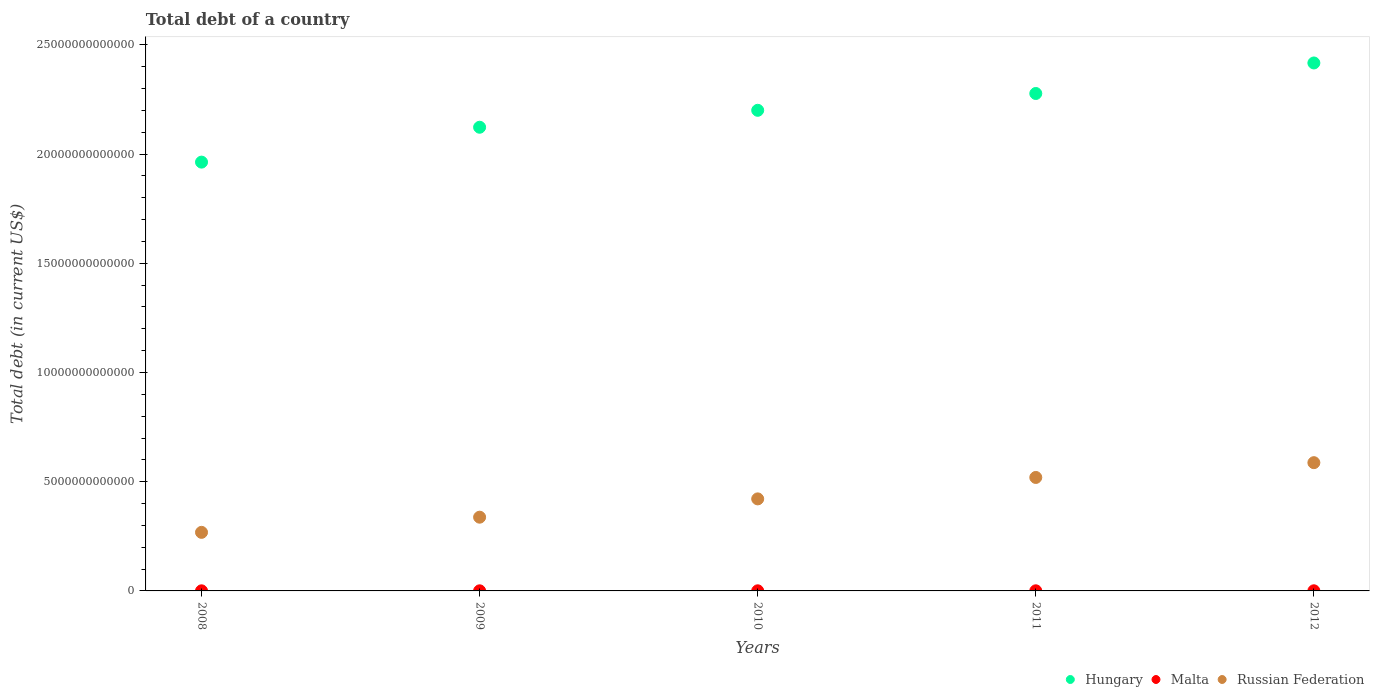Is the number of dotlines equal to the number of legend labels?
Give a very brief answer. Yes. What is the debt in Russian Federation in 2012?
Your answer should be compact. 5.87e+12. Across all years, what is the maximum debt in Hungary?
Keep it short and to the point. 2.42e+13. Across all years, what is the minimum debt in Malta?
Your response must be concise. 4.43e+09. In which year was the debt in Russian Federation minimum?
Your response must be concise. 2008. What is the total debt in Russian Federation in the graph?
Your answer should be compact. 2.13e+13. What is the difference between the debt in Malta in 2008 and that in 2010?
Make the answer very short. -6.83e+08. What is the difference between the debt in Malta in 2008 and the debt in Russian Federation in 2012?
Offer a very short reply. -5.87e+12. What is the average debt in Malta per year?
Your answer should be very brief. 5.16e+09. In the year 2012, what is the difference between the debt in Malta and debt in Hungary?
Ensure brevity in your answer.  -2.42e+13. In how many years, is the debt in Hungary greater than 18000000000000 US$?
Offer a terse response. 5. What is the ratio of the debt in Malta in 2008 to that in 2011?
Your response must be concise. 0.8. Is the debt in Malta in 2008 less than that in 2012?
Make the answer very short. Yes. Is the difference between the debt in Malta in 2010 and 2011 greater than the difference between the debt in Hungary in 2010 and 2011?
Give a very brief answer. Yes. What is the difference between the highest and the second highest debt in Russian Federation?
Give a very brief answer. 6.77e+11. What is the difference between the highest and the lowest debt in Russian Federation?
Ensure brevity in your answer.  3.19e+12. In how many years, is the debt in Hungary greater than the average debt in Hungary taken over all years?
Your answer should be compact. 3. Is the debt in Hungary strictly less than the debt in Russian Federation over the years?
Your answer should be very brief. No. How many years are there in the graph?
Your response must be concise. 5. What is the difference between two consecutive major ticks on the Y-axis?
Keep it short and to the point. 5.00e+12. Does the graph contain any zero values?
Offer a very short reply. No. Does the graph contain grids?
Ensure brevity in your answer.  No. How many legend labels are there?
Your answer should be very brief. 3. What is the title of the graph?
Offer a very short reply. Total debt of a country. What is the label or title of the Y-axis?
Make the answer very short. Total debt (in current US$). What is the Total debt (in current US$) of Hungary in 2008?
Offer a very short reply. 1.96e+13. What is the Total debt (in current US$) in Malta in 2008?
Make the answer very short. 4.43e+09. What is the Total debt (in current US$) of Russian Federation in 2008?
Ensure brevity in your answer.  2.68e+12. What is the Total debt (in current US$) of Hungary in 2009?
Give a very brief answer. 2.12e+13. What is the Total debt (in current US$) in Malta in 2009?
Keep it short and to the point. 4.78e+09. What is the Total debt (in current US$) in Russian Federation in 2009?
Your answer should be very brief. 3.38e+12. What is the Total debt (in current US$) in Hungary in 2010?
Offer a very short reply. 2.20e+13. What is the Total debt (in current US$) in Malta in 2010?
Offer a very short reply. 5.11e+09. What is the Total debt (in current US$) in Russian Federation in 2010?
Offer a very short reply. 4.21e+12. What is the Total debt (in current US$) of Hungary in 2011?
Ensure brevity in your answer.  2.28e+13. What is the Total debt (in current US$) of Malta in 2011?
Offer a very short reply. 5.54e+09. What is the Total debt (in current US$) of Russian Federation in 2011?
Provide a short and direct response. 5.19e+12. What is the Total debt (in current US$) in Hungary in 2012?
Your answer should be very brief. 2.42e+13. What is the Total debt (in current US$) in Malta in 2012?
Give a very brief answer. 5.94e+09. What is the Total debt (in current US$) of Russian Federation in 2012?
Give a very brief answer. 5.87e+12. Across all years, what is the maximum Total debt (in current US$) in Hungary?
Offer a terse response. 2.42e+13. Across all years, what is the maximum Total debt (in current US$) in Malta?
Provide a succinct answer. 5.94e+09. Across all years, what is the maximum Total debt (in current US$) in Russian Federation?
Offer a terse response. 5.87e+12. Across all years, what is the minimum Total debt (in current US$) in Hungary?
Your response must be concise. 1.96e+13. Across all years, what is the minimum Total debt (in current US$) of Malta?
Offer a terse response. 4.43e+09. Across all years, what is the minimum Total debt (in current US$) in Russian Federation?
Your response must be concise. 2.68e+12. What is the total Total debt (in current US$) in Hungary in the graph?
Ensure brevity in your answer.  1.10e+14. What is the total Total debt (in current US$) of Malta in the graph?
Provide a short and direct response. 2.58e+1. What is the total Total debt (in current US$) in Russian Federation in the graph?
Keep it short and to the point. 2.13e+13. What is the difference between the Total debt (in current US$) of Hungary in 2008 and that in 2009?
Keep it short and to the point. -1.60e+12. What is the difference between the Total debt (in current US$) in Malta in 2008 and that in 2009?
Your response must be concise. -3.48e+08. What is the difference between the Total debt (in current US$) of Russian Federation in 2008 and that in 2009?
Your answer should be compact. -6.94e+11. What is the difference between the Total debt (in current US$) in Hungary in 2008 and that in 2010?
Your answer should be very brief. -2.37e+12. What is the difference between the Total debt (in current US$) in Malta in 2008 and that in 2010?
Keep it short and to the point. -6.83e+08. What is the difference between the Total debt (in current US$) in Russian Federation in 2008 and that in 2010?
Your answer should be compact. -1.53e+12. What is the difference between the Total debt (in current US$) in Hungary in 2008 and that in 2011?
Provide a succinct answer. -3.14e+12. What is the difference between the Total debt (in current US$) of Malta in 2008 and that in 2011?
Provide a short and direct response. -1.11e+09. What is the difference between the Total debt (in current US$) in Russian Federation in 2008 and that in 2011?
Ensure brevity in your answer.  -2.51e+12. What is the difference between the Total debt (in current US$) of Hungary in 2008 and that in 2012?
Your answer should be very brief. -4.54e+12. What is the difference between the Total debt (in current US$) in Malta in 2008 and that in 2012?
Offer a very short reply. -1.51e+09. What is the difference between the Total debt (in current US$) of Russian Federation in 2008 and that in 2012?
Offer a very short reply. -3.19e+12. What is the difference between the Total debt (in current US$) of Hungary in 2009 and that in 2010?
Keep it short and to the point. -7.75e+11. What is the difference between the Total debt (in current US$) in Malta in 2009 and that in 2010?
Your answer should be compact. -3.35e+08. What is the difference between the Total debt (in current US$) in Russian Federation in 2009 and that in 2010?
Ensure brevity in your answer.  -8.38e+11. What is the difference between the Total debt (in current US$) in Hungary in 2009 and that in 2011?
Your answer should be compact. -1.54e+12. What is the difference between the Total debt (in current US$) in Malta in 2009 and that in 2011?
Ensure brevity in your answer.  -7.62e+08. What is the difference between the Total debt (in current US$) in Russian Federation in 2009 and that in 2011?
Provide a succinct answer. -1.82e+12. What is the difference between the Total debt (in current US$) of Hungary in 2009 and that in 2012?
Provide a short and direct response. -2.94e+12. What is the difference between the Total debt (in current US$) of Malta in 2009 and that in 2012?
Offer a very short reply. -1.16e+09. What is the difference between the Total debt (in current US$) of Russian Federation in 2009 and that in 2012?
Your answer should be compact. -2.50e+12. What is the difference between the Total debt (in current US$) in Hungary in 2010 and that in 2011?
Offer a very short reply. -7.70e+11. What is the difference between the Total debt (in current US$) in Malta in 2010 and that in 2011?
Provide a short and direct response. -4.27e+08. What is the difference between the Total debt (in current US$) in Russian Federation in 2010 and that in 2011?
Give a very brief answer. -9.81e+11. What is the difference between the Total debt (in current US$) in Hungary in 2010 and that in 2012?
Offer a very short reply. -2.17e+12. What is the difference between the Total debt (in current US$) of Malta in 2010 and that in 2012?
Your answer should be very brief. -8.29e+08. What is the difference between the Total debt (in current US$) of Russian Federation in 2010 and that in 2012?
Your answer should be very brief. -1.66e+12. What is the difference between the Total debt (in current US$) in Hungary in 2011 and that in 2012?
Keep it short and to the point. -1.40e+12. What is the difference between the Total debt (in current US$) of Malta in 2011 and that in 2012?
Your answer should be very brief. -4.02e+08. What is the difference between the Total debt (in current US$) of Russian Federation in 2011 and that in 2012?
Offer a terse response. -6.77e+11. What is the difference between the Total debt (in current US$) in Hungary in 2008 and the Total debt (in current US$) in Malta in 2009?
Offer a terse response. 1.96e+13. What is the difference between the Total debt (in current US$) of Hungary in 2008 and the Total debt (in current US$) of Russian Federation in 2009?
Provide a succinct answer. 1.63e+13. What is the difference between the Total debt (in current US$) in Malta in 2008 and the Total debt (in current US$) in Russian Federation in 2009?
Give a very brief answer. -3.37e+12. What is the difference between the Total debt (in current US$) of Hungary in 2008 and the Total debt (in current US$) of Malta in 2010?
Your response must be concise. 1.96e+13. What is the difference between the Total debt (in current US$) in Hungary in 2008 and the Total debt (in current US$) in Russian Federation in 2010?
Your answer should be very brief. 1.54e+13. What is the difference between the Total debt (in current US$) in Malta in 2008 and the Total debt (in current US$) in Russian Federation in 2010?
Make the answer very short. -4.21e+12. What is the difference between the Total debt (in current US$) of Hungary in 2008 and the Total debt (in current US$) of Malta in 2011?
Offer a very short reply. 1.96e+13. What is the difference between the Total debt (in current US$) in Hungary in 2008 and the Total debt (in current US$) in Russian Federation in 2011?
Your response must be concise. 1.44e+13. What is the difference between the Total debt (in current US$) of Malta in 2008 and the Total debt (in current US$) of Russian Federation in 2011?
Your answer should be compact. -5.19e+12. What is the difference between the Total debt (in current US$) in Hungary in 2008 and the Total debt (in current US$) in Malta in 2012?
Make the answer very short. 1.96e+13. What is the difference between the Total debt (in current US$) of Hungary in 2008 and the Total debt (in current US$) of Russian Federation in 2012?
Offer a terse response. 1.38e+13. What is the difference between the Total debt (in current US$) in Malta in 2008 and the Total debt (in current US$) in Russian Federation in 2012?
Ensure brevity in your answer.  -5.87e+12. What is the difference between the Total debt (in current US$) of Hungary in 2009 and the Total debt (in current US$) of Malta in 2010?
Offer a terse response. 2.12e+13. What is the difference between the Total debt (in current US$) in Hungary in 2009 and the Total debt (in current US$) in Russian Federation in 2010?
Your answer should be compact. 1.70e+13. What is the difference between the Total debt (in current US$) in Malta in 2009 and the Total debt (in current US$) in Russian Federation in 2010?
Make the answer very short. -4.21e+12. What is the difference between the Total debt (in current US$) of Hungary in 2009 and the Total debt (in current US$) of Malta in 2011?
Offer a terse response. 2.12e+13. What is the difference between the Total debt (in current US$) of Hungary in 2009 and the Total debt (in current US$) of Russian Federation in 2011?
Your answer should be compact. 1.60e+13. What is the difference between the Total debt (in current US$) of Malta in 2009 and the Total debt (in current US$) of Russian Federation in 2011?
Ensure brevity in your answer.  -5.19e+12. What is the difference between the Total debt (in current US$) in Hungary in 2009 and the Total debt (in current US$) in Malta in 2012?
Ensure brevity in your answer.  2.12e+13. What is the difference between the Total debt (in current US$) in Hungary in 2009 and the Total debt (in current US$) in Russian Federation in 2012?
Your answer should be compact. 1.54e+13. What is the difference between the Total debt (in current US$) of Malta in 2009 and the Total debt (in current US$) of Russian Federation in 2012?
Your response must be concise. -5.87e+12. What is the difference between the Total debt (in current US$) in Hungary in 2010 and the Total debt (in current US$) in Malta in 2011?
Your answer should be compact. 2.20e+13. What is the difference between the Total debt (in current US$) of Hungary in 2010 and the Total debt (in current US$) of Russian Federation in 2011?
Make the answer very short. 1.68e+13. What is the difference between the Total debt (in current US$) of Malta in 2010 and the Total debt (in current US$) of Russian Federation in 2011?
Make the answer very short. -5.19e+12. What is the difference between the Total debt (in current US$) in Hungary in 2010 and the Total debt (in current US$) in Malta in 2012?
Your response must be concise. 2.20e+13. What is the difference between the Total debt (in current US$) of Hungary in 2010 and the Total debt (in current US$) of Russian Federation in 2012?
Provide a succinct answer. 1.61e+13. What is the difference between the Total debt (in current US$) in Malta in 2010 and the Total debt (in current US$) in Russian Federation in 2012?
Your answer should be compact. -5.87e+12. What is the difference between the Total debt (in current US$) in Hungary in 2011 and the Total debt (in current US$) in Malta in 2012?
Give a very brief answer. 2.28e+13. What is the difference between the Total debt (in current US$) of Hungary in 2011 and the Total debt (in current US$) of Russian Federation in 2012?
Give a very brief answer. 1.69e+13. What is the difference between the Total debt (in current US$) in Malta in 2011 and the Total debt (in current US$) in Russian Federation in 2012?
Give a very brief answer. -5.87e+12. What is the average Total debt (in current US$) of Hungary per year?
Keep it short and to the point. 2.20e+13. What is the average Total debt (in current US$) in Malta per year?
Your answer should be compact. 5.16e+09. What is the average Total debt (in current US$) in Russian Federation per year?
Offer a terse response. 4.27e+12. In the year 2008, what is the difference between the Total debt (in current US$) in Hungary and Total debt (in current US$) in Malta?
Keep it short and to the point. 1.96e+13. In the year 2008, what is the difference between the Total debt (in current US$) of Hungary and Total debt (in current US$) of Russian Federation?
Your response must be concise. 1.69e+13. In the year 2008, what is the difference between the Total debt (in current US$) in Malta and Total debt (in current US$) in Russian Federation?
Offer a very short reply. -2.68e+12. In the year 2009, what is the difference between the Total debt (in current US$) of Hungary and Total debt (in current US$) of Malta?
Provide a short and direct response. 2.12e+13. In the year 2009, what is the difference between the Total debt (in current US$) in Hungary and Total debt (in current US$) in Russian Federation?
Ensure brevity in your answer.  1.79e+13. In the year 2009, what is the difference between the Total debt (in current US$) in Malta and Total debt (in current US$) in Russian Federation?
Keep it short and to the point. -3.37e+12. In the year 2010, what is the difference between the Total debt (in current US$) of Hungary and Total debt (in current US$) of Malta?
Your answer should be compact. 2.20e+13. In the year 2010, what is the difference between the Total debt (in current US$) in Hungary and Total debt (in current US$) in Russian Federation?
Your response must be concise. 1.78e+13. In the year 2010, what is the difference between the Total debt (in current US$) of Malta and Total debt (in current US$) of Russian Federation?
Offer a very short reply. -4.21e+12. In the year 2011, what is the difference between the Total debt (in current US$) in Hungary and Total debt (in current US$) in Malta?
Provide a short and direct response. 2.28e+13. In the year 2011, what is the difference between the Total debt (in current US$) of Hungary and Total debt (in current US$) of Russian Federation?
Your response must be concise. 1.76e+13. In the year 2011, what is the difference between the Total debt (in current US$) in Malta and Total debt (in current US$) in Russian Federation?
Offer a terse response. -5.19e+12. In the year 2012, what is the difference between the Total debt (in current US$) of Hungary and Total debt (in current US$) of Malta?
Give a very brief answer. 2.42e+13. In the year 2012, what is the difference between the Total debt (in current US$) of Hungary and Total debt (in current US$) of Russian Federation?
Your answer should be very brief. 1.83e+13. In the year 2012, what is the difference between the Total debt (in current US$) in Malta and Total debt (in current US$) in Russian Federation?
Ensure brevity in your answer.  -5.87e+12. What is the ratio of the Total debt (in current US$) of Hungary in 2008 to that in 2009?
Your answer should be very brief. 0.92. What is the ratio of the Total debt (in current US$) in Malta in 2008 to that in 2009?
Provide a succinct answer. 0.93. What is the ratio of the Total debt (in current US$) of Russian Federation in 2008 to that in 2009?
Your response must be concise. 0.79. What is the ratio of the Total debt (in current US$) of Hungary in 2008 to that in 2010?
Ensure brevity in your answer.  0.89. What is the ratio of the Total debt (in current US$) in Malta in 2008 to that in 2010?
Your answer should be compact. 0.87. What is the ratio of the Total debt (in current US$) of Russian Federation in 2008 to that in 2010?
Give a very brief answer. 0.64. What is the ratio of the Total debt (in current US$) of Hungary in 2008 to that in 2011?
Keep it short and to the point. 0.86. What is the ratio of the Total debt (in current US$) of Malta in 2008 to that in 2011?
Your answer should be very brief. 0.8. What is the ratio of the Total debt (in current US$) of Russian Federation in 2008 to that in 2011?
Your response must be concise. 0.52. What is the ratio of the Total debt (in current US$) of Hungary in 2008 to that in 2012?
Provide a short and direct response. 0.81. What is the ratio of the Total debt (in current US$) in Malta in 2008 to that in 2012?
Offer a terse response. 0.75. What is the ratio of the Total debt (in current US$) in Russian Federation in 2008 to that in 2012?
Give a very brief answer. 0.46. What is the ratio of the Total debt (in current US$) of Hungary in 2009 to that in 2010?
Offer a very short reply. 0.96. What is the ratio of the Total debt (in current US$) of Malta in 2009 to that in 2010?
Make the answer very short. 0.93. What is the ratio of the Total debt (in current US$) in Russian Federation in 2009 to that in 2010?
Your answer should be very brief. 0.8. What is the ratio of the Total debt (in current US$) in Hungary in 2009 to that in 2011?
Provide a succinct answer. 0.93. What is the ratio of the Total debt (in current US$) in Malta in 2009 to that in 2011?
Your answer should be compact. 0.86. What is the ratio of the Total debt (in current US$) in Russian Federation in 2009 to that in 2011?
Your answer should be compact. 0.65. What is the ratio of the Total debt (in current US$) of Hungary in 2009 to that in 2012?
Your answer should be compact. 0.88. What is the ratio of the Total debt (in current US$) in Malta in 2009 to that in 2012?
Offer a very short reply. 0.8. What is the ratio of the Total debt (in current US$) of Russian Federation in 2009 to that in 2012?
Your answer should be very brief. 0.57. What is the ratio of the Total debt (in current US$) in Hungary in 2010 to that in 2011?
Your answer should be very brief. 0.97. What is the ratio of the Total debt (in current US$) in Malta in 2010 to that in 2011?
Provide a succinct answer. 0.92. What is the ratio of the Total debt (in current US$) in Russian Federation in 2010 to that in 2011?
Keep it short and to the point. 0.81. What is the ratio of the Total debt (in current US$) of Hungary in 2010 to that in 2012?
Offer a very short reply. 0.91. What is the ratio of the Total debt (in current US$) of Malta in 2010 to that in 2012?
Keep it short and to the point. 0.86. What is the ratio of the Total debt (in current US$) of Russian Federation in 2010 to that in 2012?
Give a very brief answer. 0.72. What is the ratio of the Total debt (in current US$) in Hungary in 2011 to that in 2012?
Your answer should be very brief. 0.94. What is the ratio of the Total debt (in current US$) of Malta in 2011 to that in 2012?
Provide a short and direct response. 0.93. What is the ratio of the Total debt (in current US$) of Russian Federation in 2011 to that in 2012?
Your response must be concise. 0.88. What is the difference between the highest and the second highest Total debt (in current US$) in Hungary?
Your answer should be very brief. 1.40e+12. What is the difference between the highest and the second highest Total debt (in current US$) of Malta?
Provide a succinct answer. 4.02e+08. What is the difference between the highest and the second highest Total debt (in current US$) of Russian Federation?
Your answer should be compact. 6.77e+11. What is the difference between the highest and the lowest Total debt (in current US$) in Hungary?
Offer a very short reply. 4.54e+12. What is the difference between the highest and the lowest Total debt (in current US$) of Malta?
Offer a terse response. 1.51e+09. What is the difference between the highest and the lowest Total debt (in current US$) in Russian Federation?
Provide a short and direct response. 3.19e+12. 